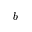Convert formula to latex. <formula><loc_0><loc_0><loc_500><loc_500>b</formula> 